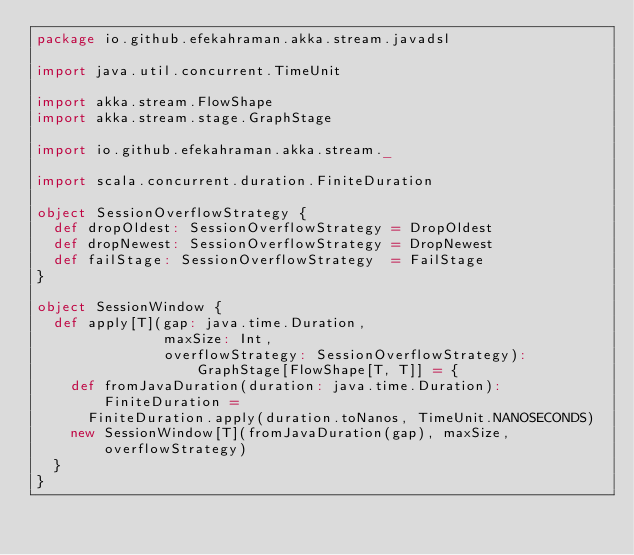Convert code to text. <code><loc_0><loc_0><loc_500><loc_500><_Scala_>package io.github.efekahraman.akka.stream.javadsl

import java.util.concurrent.TimeUnit

import akka.stream.FlowShape
import akka.stream.stage.GraphStage

import io.github.efekahraman.akka.stream._

import scala.concurrent.duration.FiniteDuration

object SessionOverflowStrategy {
  def dropOldest: SessionOverflowStrategy = DropOldest
  def dropNewest: SessionOverflowStrategy = DropNewest
  def failStage: SessionOverflowStrategy  = FailStage
}

object SessionWindow {
  def apply[T](gap: java.time.Duration,
               maxSize: Int,
               overflowStrategy: SessionOverflowStrategy): GraphStage[FlowShape[T, T]] = {
    def fromJavaDuration(duration: java.time.Duration): FiniteDuration =
      FiniteDuration.apply(duration.toNanos, TimeUnit.NANOSECONDS)
    new SessionWindow[T](fromJavaDuration(gap), maxSize, overflowStrategy)
  }
}
</code> 